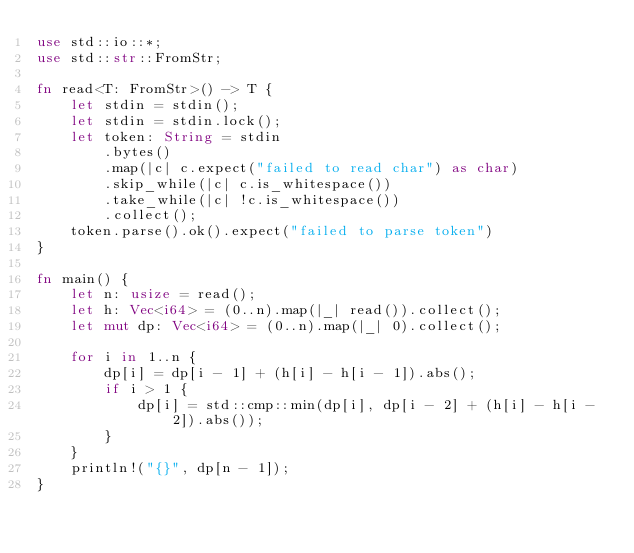Convert code to text. <code><loc_0><loc_0><loc_500><loc_500><_Rust_>use std::io::*;
use std::str::FromStr;

fn read<T: FromStr>() -> T {
    let stdin = stdin();
    let stdin = stdin.lock();
    let token: String = stdin
        .bytes()
        .map(|c| c.expect("failed to read char") as char) 
        .skip_while(|c| c.is_whitespace())
        .take_while(|c| !c.is_whitespace())
        .collect();
    token.parse().ok().expect("failed to parse token")
}

fn main() {
    let n: usize = read();
    let h: Vec<i64> = (0..n).map(|_| read()).collect();
    let mut dp: Vec<i64> = (0..n).map(|_| 0).collect();

    for i in 1..n {
        dp[i] = dp[i - 1] + (h[i] - h[i - 1]).abs();
        if i > 1 {
            dp[i] = std::cmp::min(dp[i], dp[i - 2] + (h[i] - h[i - 2]).abs());
        }
    }
    println!("{}", dp[n - 1]);
}
</code> 